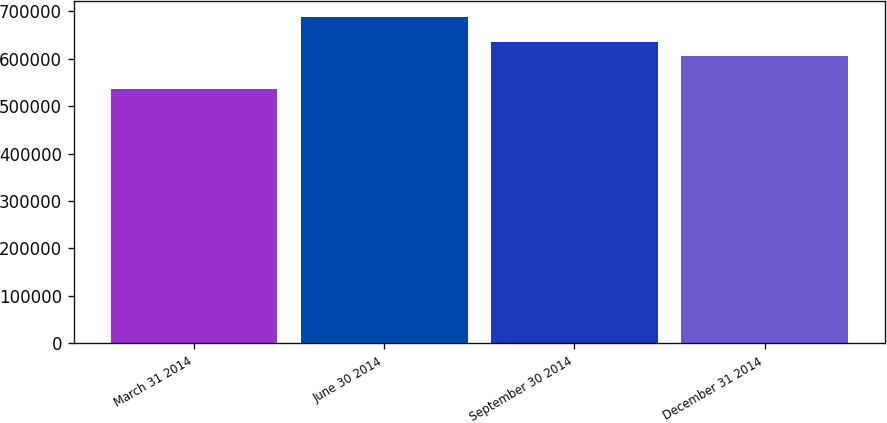Convert chart to OTSL. <chart><loc_0><loc_0><loc_500><loc_500><bar_chart><fcel>March 31 2014<fcel>June 30 2014<fcel>September 30 2014<fcel>December 31 2014<nl><fcel>536129<fcel>687199<fcel>635972<fcel>605567<nl></chart> 